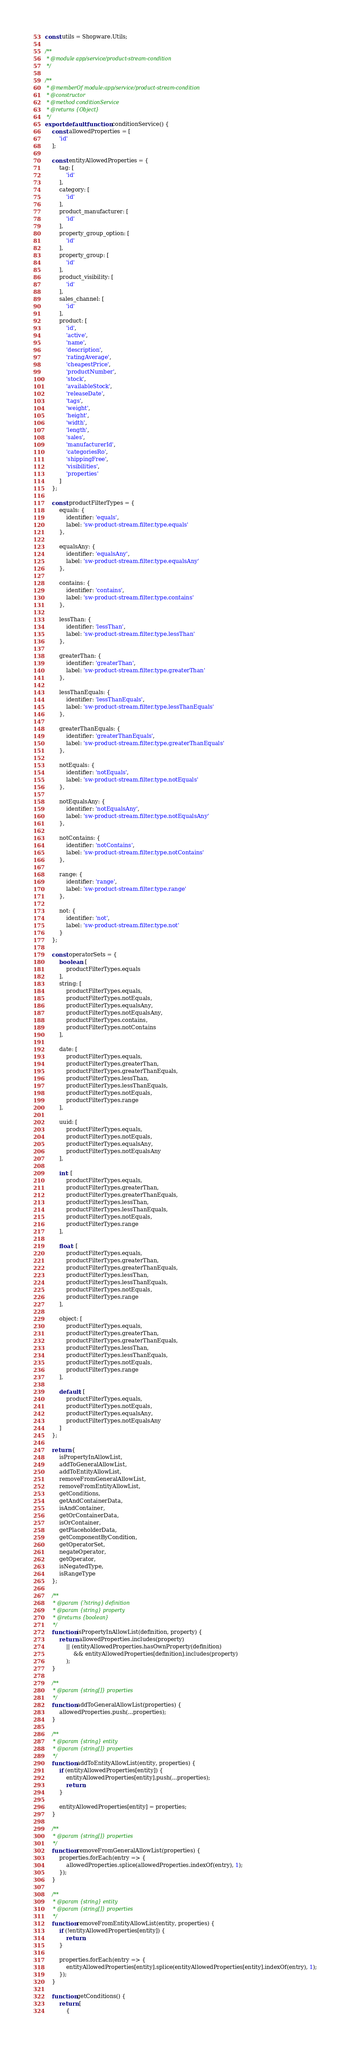Convert code to text. <code><loc_0><loc_0><loc_500><loc_500><_JavaScript_>const utils = Shopware.Utils;

/**
 * @module app/service/product-stream-condition
 */

/**
 * @memberOf module:app/service/product-stream-condition
 * @constructor
 * @method conditionService
 * @returns {Object}
 */
export default function conditionService() {
    const allowedProperties = [
        'id'
    ];

    const entityAllowedProperties = {
        tag: [
            'id'
        ],
        category: [
            'id'
        ],
        product_manufacturer: [
            'id'
        ],
        property_group_option: [
            'id'
        ],
        property_group: [
            'id'
        ],
        product_visibility: [
            'id'
        ],
        sales_channel: [
            'id'
        ],
        product: [
            'id',
            'active',
            'name',
            'description',
            'ratingAverage',
            'cheapestPrice',
            'productNumber',
            'stock',
            'availableStock',
            'releaseDate',
            'tags',
            'weight',
            'height',
            'width',
            'length',
            'sales',
            'manufacturerId',
            'categoriesRo',
            'shippingFree',
            'visibilities',
            'properties'
        ]
    };

    const productFilterTypes = {
        equals: {
            identifier: 'equals',
            label: 'sw-product-stream.filter.type.equals'
        },

        equalsAny: {
            identifier: 'equalsAny',
            label: 'sw-product-stream.filter.type.equalsAny'
        },

        contains: {
            identifier: 'contains',
            label: 'sw-product-stream.filter.type.contains'
        },

        lessThan: {
            identifier: 'lessThan',
            label: 'sw-product-stream.filter.type.lessThan'
        },

        greaterThan: {
            identifier: 'greaterThan',
            label: 'sw-product-stream.filter.type.greaterThan'
        },

        lessThanEquals: {
            identifier: 'lessThanEquals',
            label: 'sw-product-stream.filter.type.lessThanEquals'
        },

        greaterThanEquals: {
            identifier: 'greaterThanEquals',
            label: 'sw-product-stream.filter.type.greaterThanEquals'
        },

        notEquals: {
            identifier: 'notEquals',
            label: 'sw-product-stream.filter.type.notEquals'
        },

        notEqualsAny: {
            identifier: 'notEqualsAny',
            label: 'sw-product-stream.filter.type.notEqualsAny'
        },

        notContains: {
            identifier: 'notContains',
            label: 'sw-product-stream.filter.type.notContains'
        },

        range: {
            identifier: 'range',
            label: 'sw-product-stream.filter.type.range'
        },

        not: {
            identifier: 'not',
            label: 'sw-product-stream.filter.type.not'
        }
    };

    const operatorSets = {
        boolean: [
            productFilterTypes.equals
        ],
        string: [
            productFilterTypes.equals,
            productFilterTypes.notEquals,
            productFilterTypes.equalsAny,
            productFilterTypes.notEqualsAny,
            productFilterTypes.contains,
            productFilterTypes.notContains
        ],

        date: [
            productFilterTypes.equals,
            productFilterTypes.greaterThan,
            productFilterTypes.greaterThanEquals,
            productFilterTypes.lessThan,
            productFilterTypes.lessThanEquals,
            productFilterTypes.notEquals,
            productFilterTypes.range
        ],

        uuid: [
            productFilterTypes.equals,
            productFilterTypes.notEquals,
            productFilterTypes.equalsAny,
            productFilterTypes.notEqualsAny
        ],

        int: [
            productFilterTypes.equals,
            productFilterTypes.greaterThan,
            productFilterTypes.greaterThanEquals,
            productFilterTypes.lessThan,
            productFilterTypes.lessThanEquals,
            productFilterTypes.notEquals,
            productFilterTypes.range
        ],

        float: [
            productFilterTypes.equals,
            productFilterTypes.greaterThan,
            productFilterTypes.greaterThanEquals,
            productFilterTypes.lessThan,
            productFilterTypes.lessThanEquals,
            productFilterTypes.notEquals,
            productFilterTypes.range
        ],

        object: [
            productFilterTypes.equals,
            productFilterTypes.greaterThan,
            productFilterTypes.greaterThanEquals,
            productFilterTypes.lessThan,
            productFilterTypes.lessThanEquals,
            productFilterTypes.notEquals,
            productFilterTypes.range
        ],

        default: [
            productFilterTypes.equals,
            productFilterTypes.notEquals,
            productFilterTypes.equalsAny,
            productFilterTypes.notEqualsAny
        ]
    };

    return {
        isPropertyInAllowList,
        addToGeneralAllowList,
        addToEntityAllowList,
        removeFromGeneralAllowList,
        removeFromEntityAllowList,
        getConditions,
        getAndContainerData,
        isAndContainer,
        getOrContainerData,
        isOrContainer,
        getPlaceholderData,
        getComponentByCondition,
        getOperatorSet,
        negateOperator,
        getOperator,
        isNegatedType,
        isRangeType
    };

    /**
     * @param {?string} definition
     * @param {string} property
     * @returns {boolean}
     */
    function isPropertyInAllowList(definition, property) {
        return allowedProperties.includes(property)
            || (entityAllowedProperties.hasOwnProperty(definition)
                && entityAllowedProperties[definition].includes(property)
            );
    }

    /**
     * @param {string[]} properties
     */
    function addToGeneralAllowList(properties) {
        allowedProperties.push(...properties);
    }

    /**
     * @param {string} entity
     * @param {string[]} properties
     */
    function addToEntityAllowList(entity, properties) {
        if (entityAllowedProperties[entity]) {
            entityAllowedProperties[entity].push(...properties);
            return;
        }

        entityAllowedProperties[entity] = properties;
    }

    /**
     * @param {string[]} properties
     */
    function removeFromGeneralAllowList(properties) {
        properties.forEach(entry => {
            allowedProperties.splice(allowedProperties.indexOf(entry), 1);
        });
    }

    /**
     * @param {string} entity
     * @param {string[]} properties
     */
    function removeFromEntityAllowList(entity, properties) {
        if (!entityAllowedProperties[entity]) {
            return;
        }

        properties.forEach(entry => {
            entityAllowedProperties[entity].splice(entityAllowedProperties[entity].indexOf(entry), 1);
        });
    }

    function getConditions() {
        return [
            {</code> 